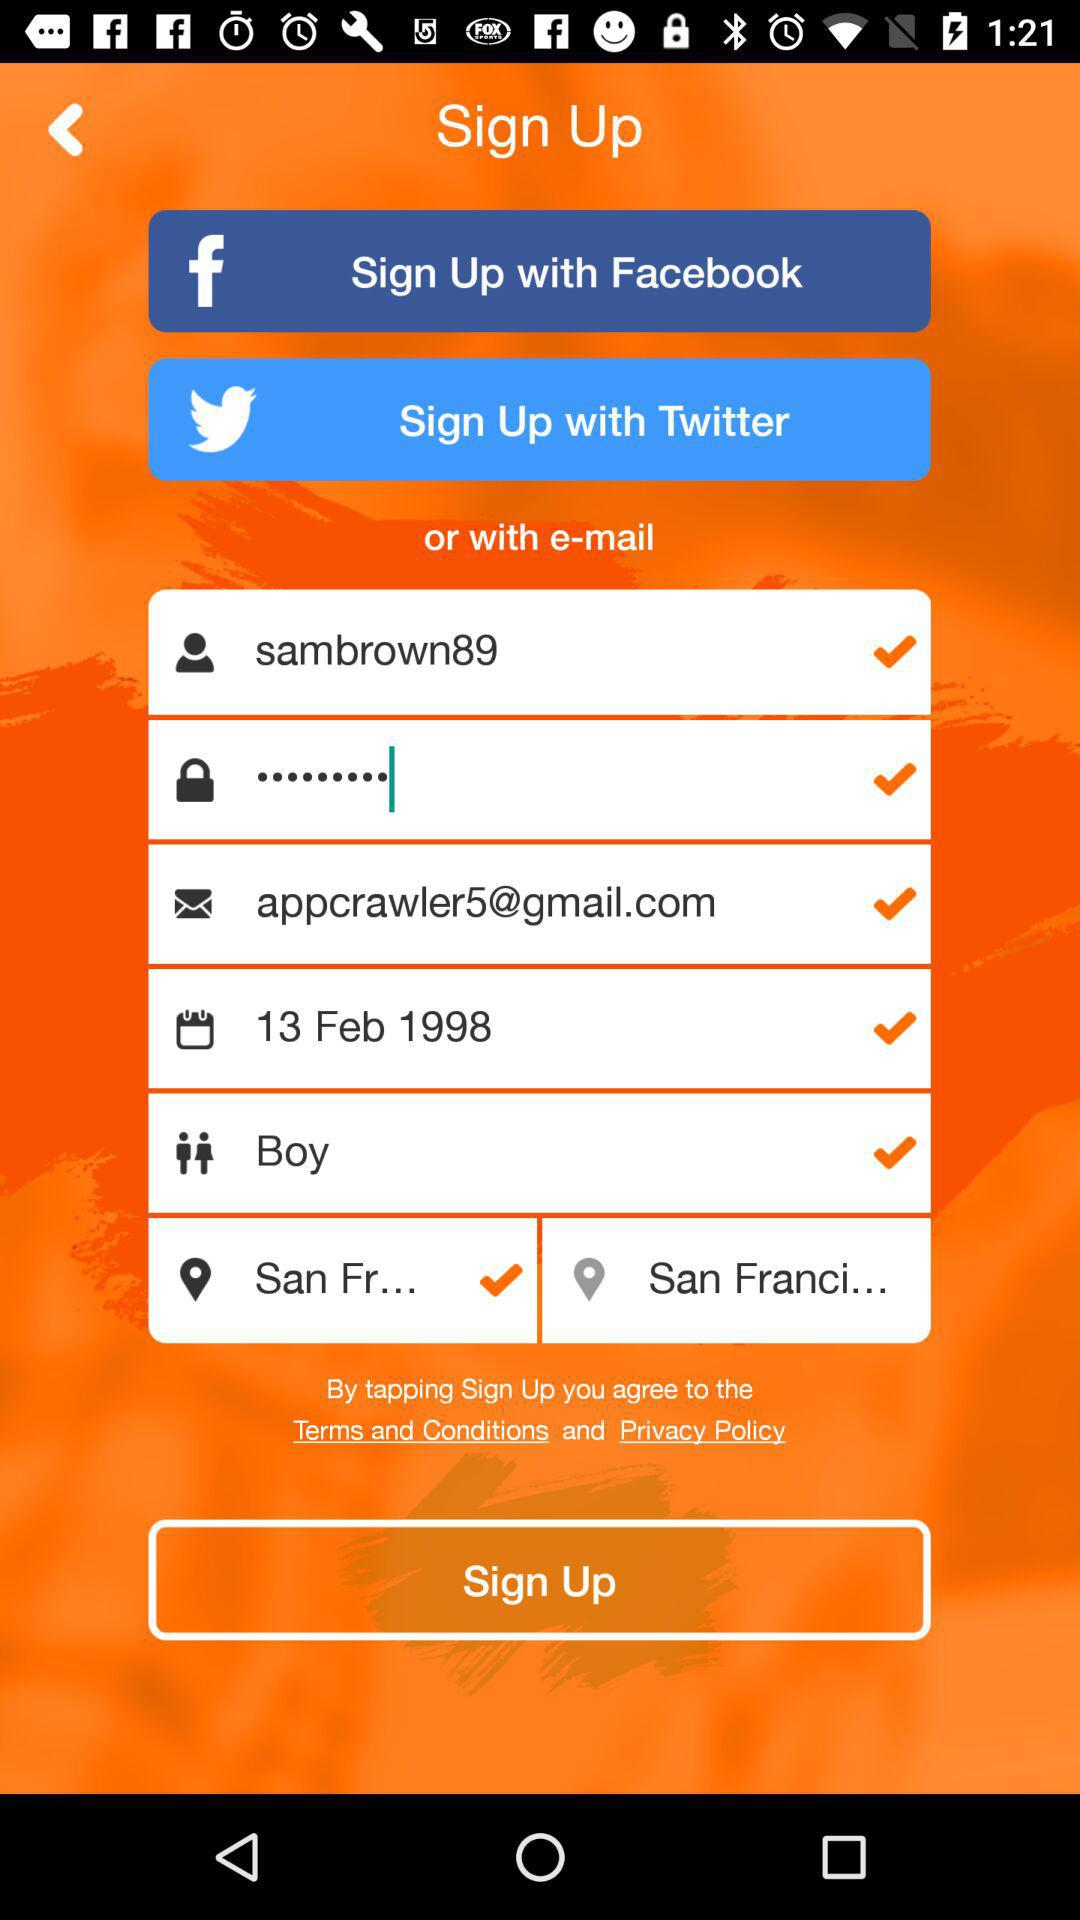Which gender is selected? It is a boy. 